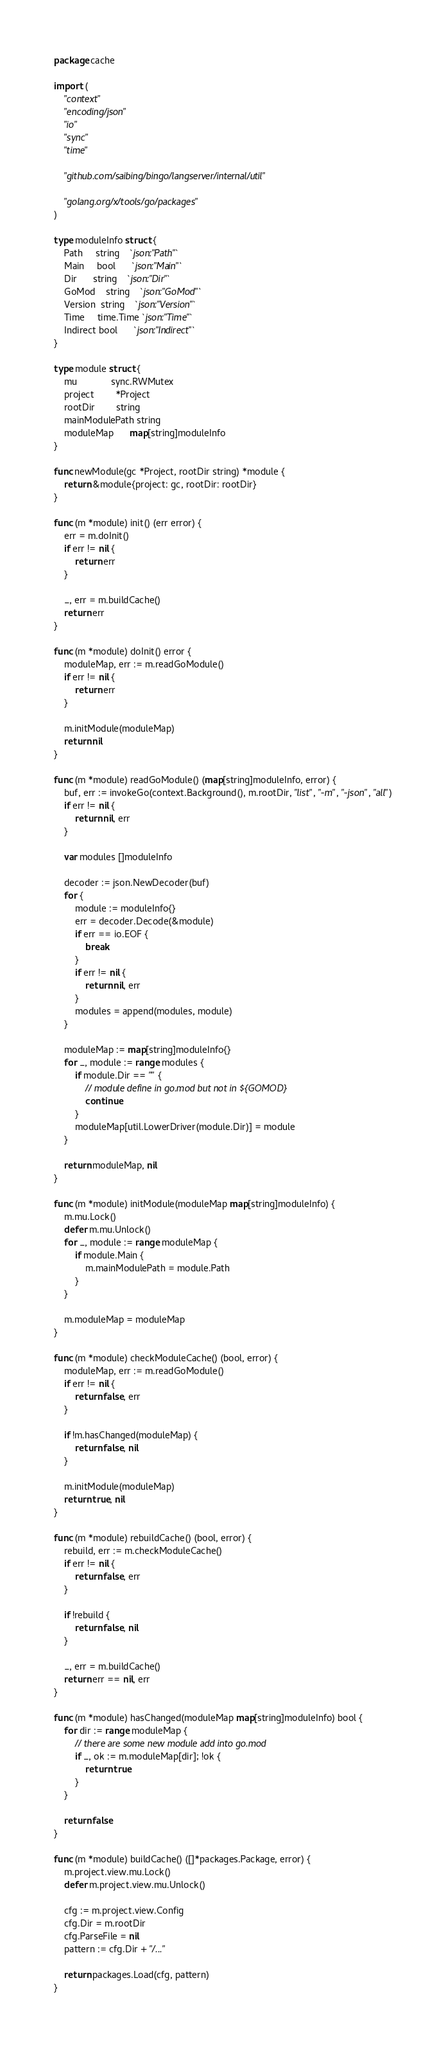Convert code to text. <code><loc_0><loc_0><loc_500><loc_500><_Go_>package cache

import (
	"context"
	"encoding/json"
	"io"
	"sync"
	"time"

	"github.com/saibing/bingo/langserver/internal/util"

	"golang.org/x/tools/go/packages"
)

type moduleInfo struct {
	Path     string    `json:"Path"`
	Main     bool      `json:"Main"`
	Dir      string    `json:"Dir"`
	GoMod    string    `json:"GoMod"`
	Version  string    `json:"Version"`
	Time     time.Time `json:"Time"`
	Indirect bool      `json:"Indirect"`
}

type module struct {
	mu             sync.RWMutex
	project        *Project
	rootDir        string
	mainModulePath string
	moduleMap      map[string]moduleInfo
}

func newModule(gc *Project, rootDir string) *module {
	return &module{project: gc, rootDir: rootDir}
}

func (m *module) init() (err error) {
	err = m.doInit()
	if err != nil {
		return err
	}

	_, err = m.buildCache()
	return err
}

func (m *module) doInit() error {
	moduleMap, err := m.readGoModule()
	if err != nil {
		return err
	}

	m.initModule(moduleMap)
	return nil
}

func (m *module) readGoModule() (map[string]moduleInfo, error) {
	buf, err := invokeGo(context.Background(), m.rootDir, "list", "-m", "-json", "all")
	if err != nil {
		return nil, err
	}

	var modules []moduleInfo

	decoder := json.NewDecoder(buf)
	for {
		module := moduleInfo{}
		err = decoder.Decode(&module)
		if err == io.EOF {
			break
		}
		if err != nil {
			return nil, err
		}
		modules = append(modules, module)
	}

	moduleMap := map[string]moduleInfo{}
	for _, module := range modules {
		if module.Dir == "" {
			// module define in go.mod but not in ${GOMOD}
			continue
		}
		moduleMap[util.LowerDriver(module.Dir)] = module
	}

	return moduleMap, nil
}

func (m *module) initModule(moduleMap map[string]moduleInfo) {
	m.mu.Lock()
	defer m.mu.Unlock()
	for _, module := range moduleMap {
		if module.Main {
			m.mainModulePath = module.Path
		}
	}

	m.moduleMap = moduleMap
}

func (m *module) checkModuleCache() (bool, error) {
	moduleMap, err := m.readGoModule()
	if err != nil {
		return false, err
	}

	if !m.hasChanged(moduleMap) {
		return false, nil
	}

	m.initModule(moduleMap)
	return true, nil
}

func (m *module) rebuildCache() (bool, error) {
	rebuild, err := m.checkModuleCache()
	if err != nil {
		return false, err
	}

	if !rebuild {
		return false, nil
	}

	_, err = m.buildCache()
	return err == nil, err
}

func (m *module) hasChanged(moduleMap map[string]moduleInfo) bool {
	for dir := range moduleMap {
		// there are some new module add into go.mod
		if _, ok := m.moduleMap[dir]; !ok {
			return true
		}
	}

	return false
}

func (m *module) buildCache() ([]*packages.Package, error) {
	m.project.view.mu.Lock()
	defer m.project.view.mu.Unlock()

	cfg := m.project.view.Config
	cfg.Dir = m.rootDir
	cfg.ParseFile = nil
	pattern := cfg.Dir + "/..."

	return packages.Load(cfg, pattern)
}

</code> 